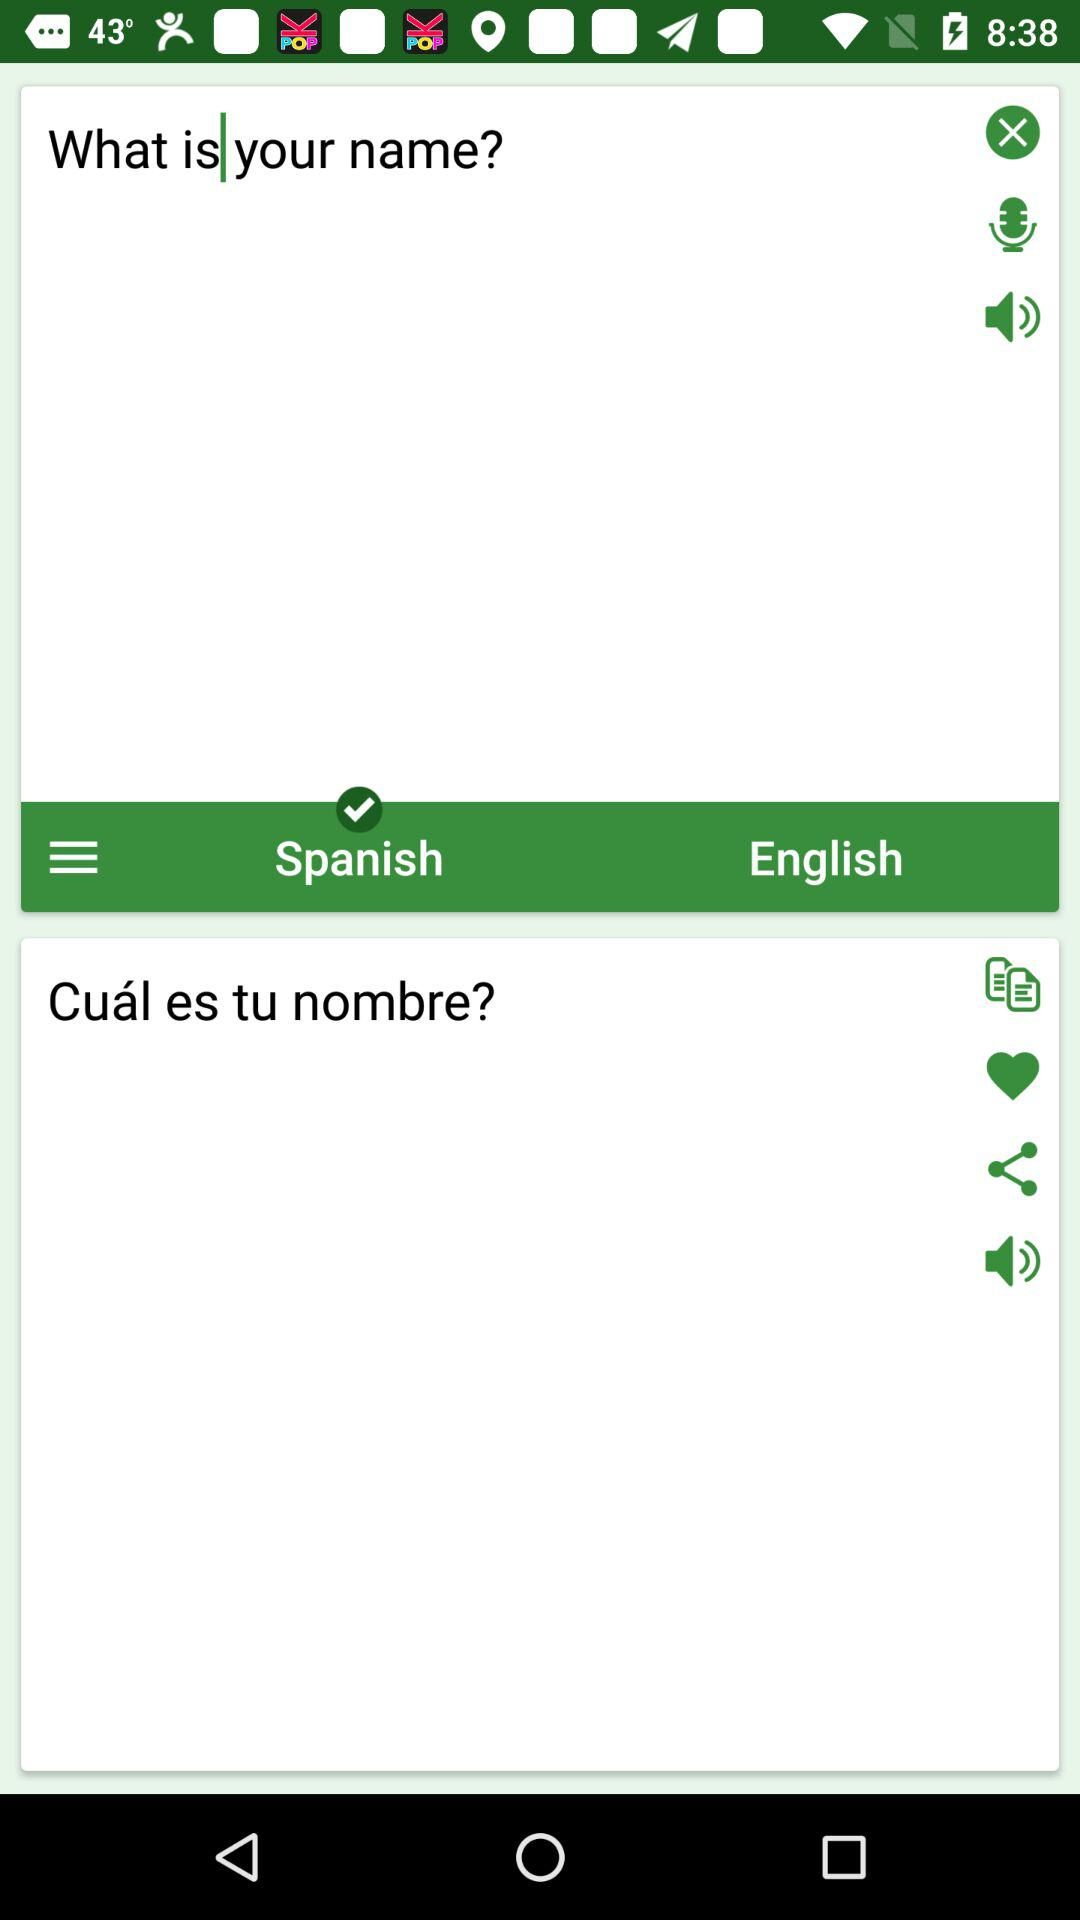What is the language translation paired with Spanish in the current selection? The paired language is English. 